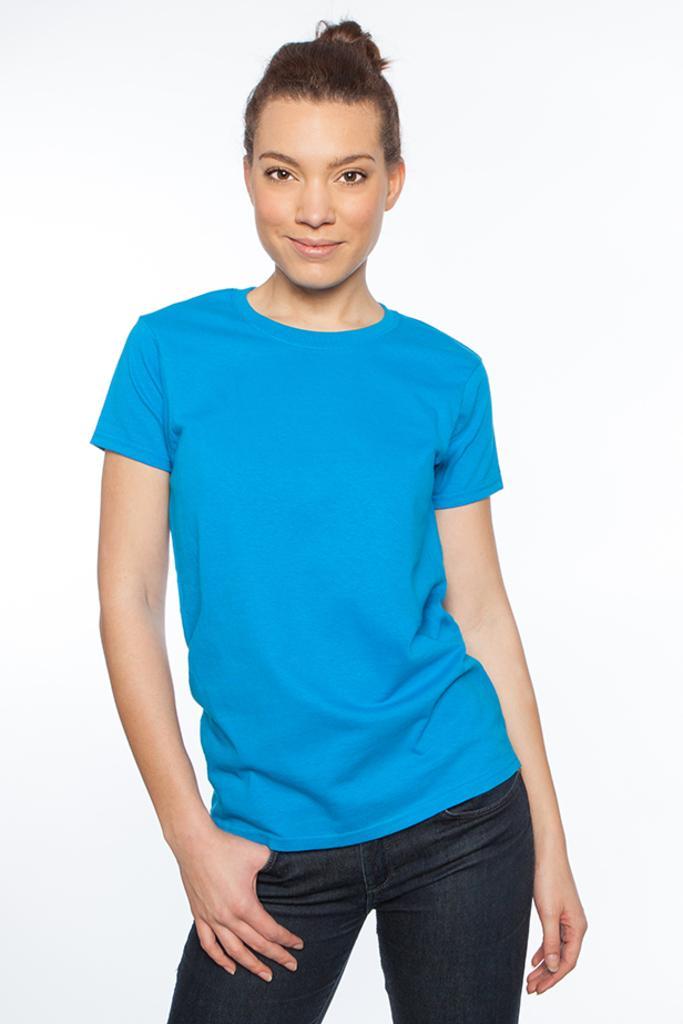In one or two sentences, can you explain what this image depicts? In this image we can see a woman standing and wearing a blue shirt and a black jeans and a white background. 